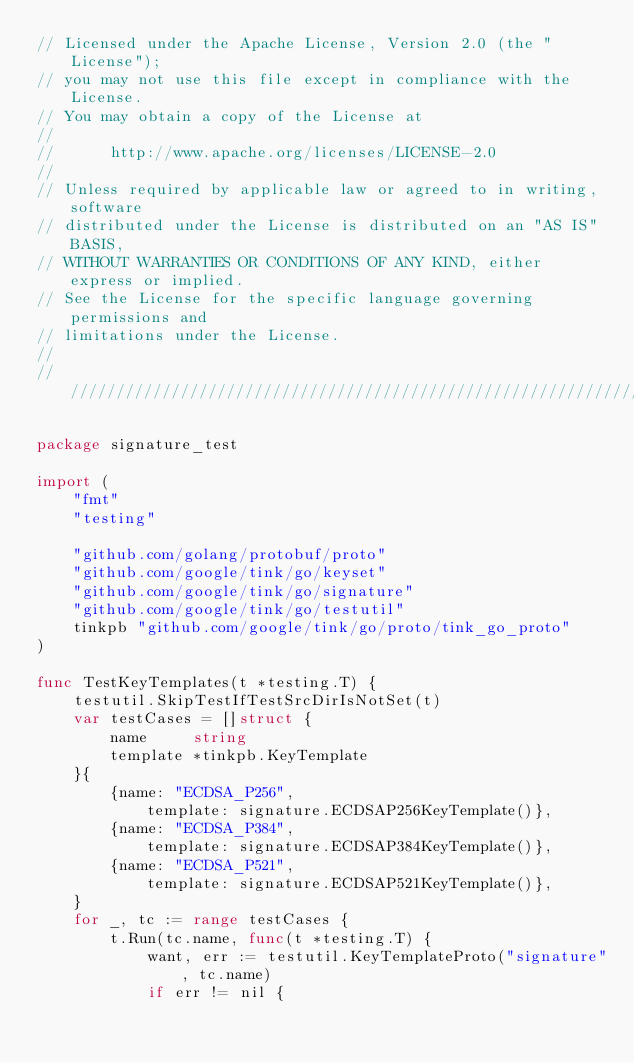Convert code to text. <code><loc_0><loc_0><loc_500><loc_500><_Go_>// Licensed under the Apache License, Version 2.0 (the "License");
// you may not use this file except in compliance with the License.
// You may obtain a copy of the License at
//
//      http://www.apache.org/licenses/LICENSE-2.0
//
// Unless required by applicable law or agreed to in writing, software
// distributed under the License is distributed on an "AS IS" BASIS,
// WITHOUT WARRANTIES OR CONDITIONS OF ANY KIND, either express or implied.
// See the License for the specific language governing permissions and
// limitations under the License.
//
////////////////////////////////////////////////////////////////////////////////

package signature_test

import (
	"fmt"
	"testing"

	"github.com/golang/protobuf/proto"
	"github.com/google/tink/go/keyset"
	"github.com/google/tink/go/signature"
	"github.com/google/tink/go/testutil"
	tinkpb "github.com/google/tink/go/proto/tink_go_proto"
)

func TestKeyTemplates(t *testing.T) {
	testutil.SkipTestIfTestSrcDirIsNotSet(t)
	var testCases = []struct {
		name     string
		template *tinkpb.KeyTemplate
	}{
		{name: "ECDSA_P256",
			template: signature.ECDSAP256KeyTemplate()},
		{name: "ECDSA_P384",
			template: signature.ECDSAP384KeyTemplate()},
		{name: "ECDSA_P521",
			template: signature.ECDSAP521KeyTemplate()},
	}
	for _, tc := range testCases {
		t.Run(tc.name, func(t *testing.T) {
			want, err := testutil.KeyTemplateProto("signature", tc.name)
			if err != nil {</code> 